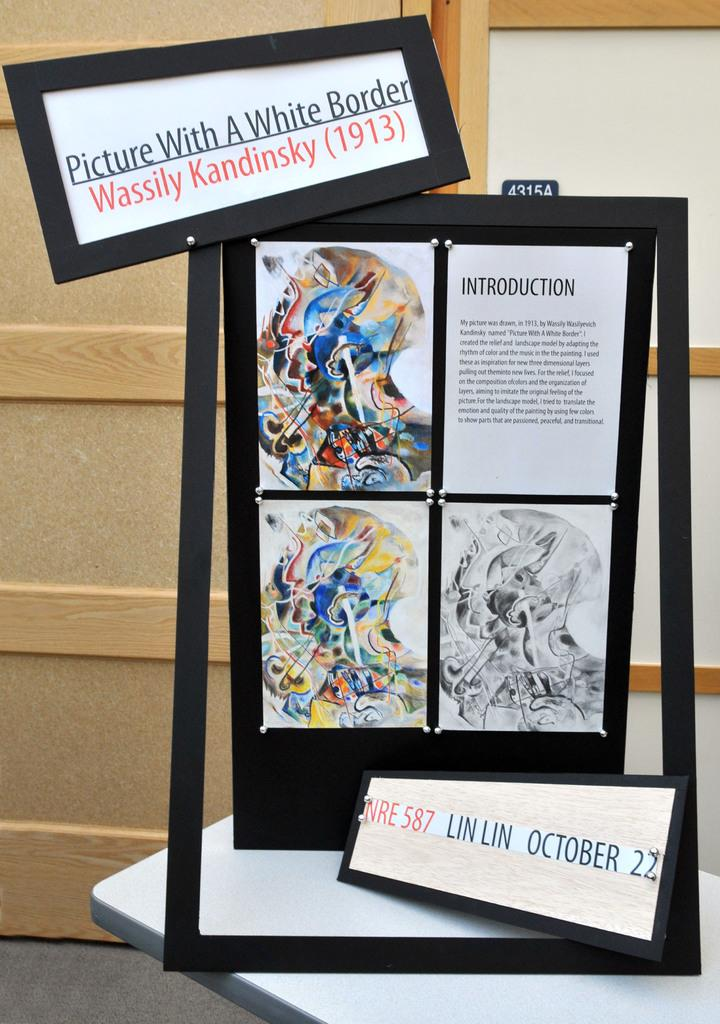Provide a one-sentence caption for the provided image. In 1913, an artist by the name of Wassily Kandinsky created a piece of art titled Picture With A White Border. 